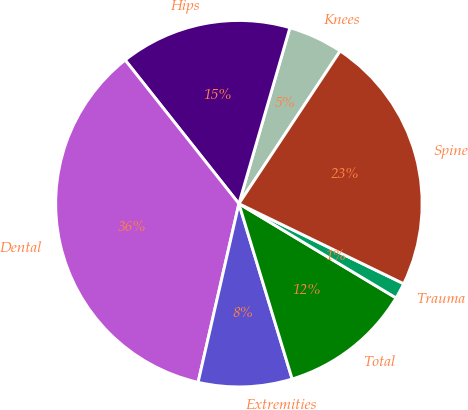Convert chart. <chart><loc_0><loc_0><loc_500><loc_500><pie_chart><fcel>Knees<fcel>Hips<fcel>Dental<fcel>Extremities<fcel>Total<fcel>Trauma<fcel>Spine<nl><fcel>4.83%<fcel>15.15%<fcel>35.77%<fcel>8.27%<fcel>11.71%<fcel>1.4%<fcel>22.88%<nl></chart> 